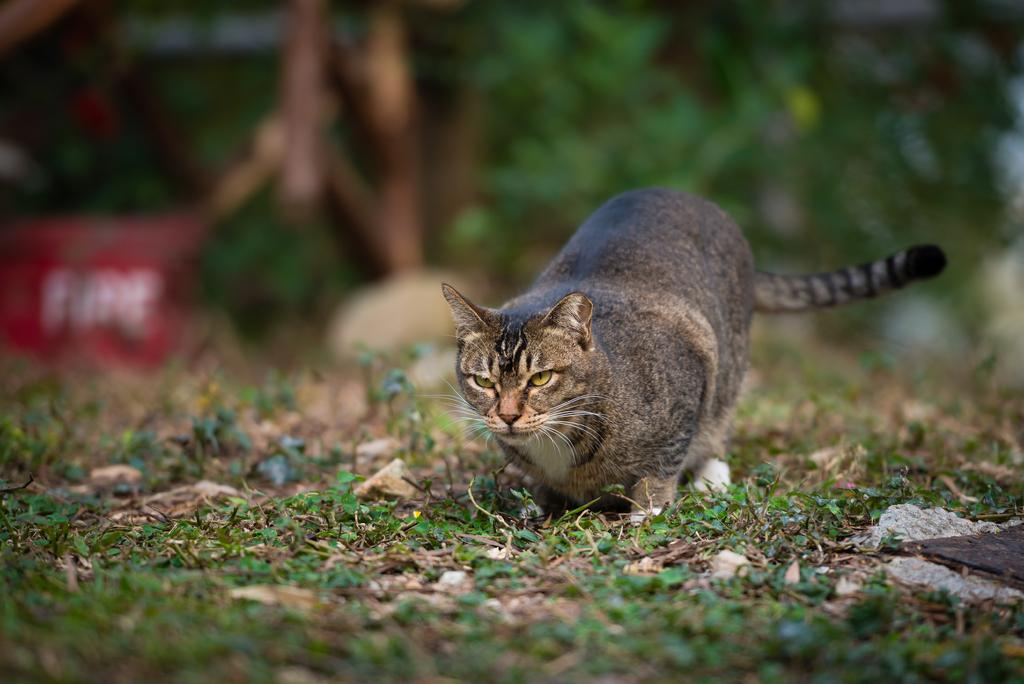What type of animal is on the ground in the image? There is a cat on the ground in the image. What else can be seen in the image besides the cat? Plants are visible in the image. Can you describe the background of the image? The background of the image is blurred. What type of brake system is present on the cat in the image? There is no brake system present on the cat in the image, as cats do not have brake systems. 